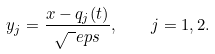Convert formula to latex. <formula><loc_0><loc_0><loc_500><loc_500>y _ { j } = \frac { x - q _ { j } ( t ) } { \sqrt { \ } e p s } , \quad j = 1 , 2 .</formula> 